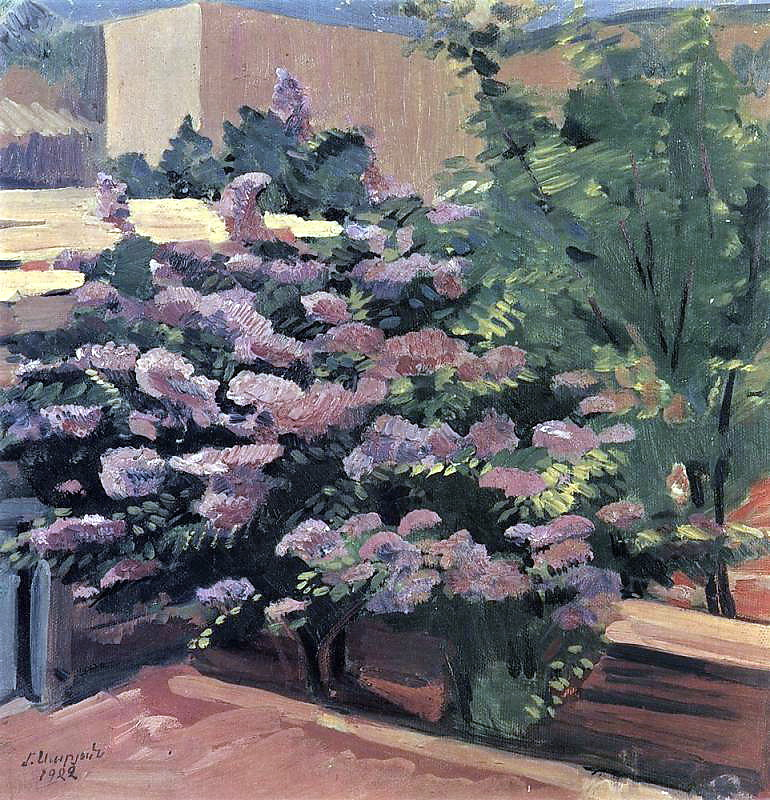Imagine you are in this garden. Describe what you would hear, smell, and feel. If you were in this serene garden, you would be enveloped by the melodious chirping of birds hidden among the trees, the gentle rustle of leaves swaying in the breeze, and the distant hum of bees and other insects busily pollinating. The air would be filled with the delicate fragrance of blooming flowers combined with the earthy scent of damp soil. As you touch the petals of the flowers, they feel soft and velvety against your fingertips, while the leaves are cool and smooth. The warmth of the sun filters through the foliage, casting dappled shadows and creating a perfect balance of light and shade, making you feel both tranquil and rejuvenated in this natural haven. 